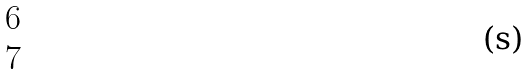<formula> <loc_0><loc_0><loc_500><loc_500>\begin{matrix} 6 \\ 7 \end{matrix}</formula> 